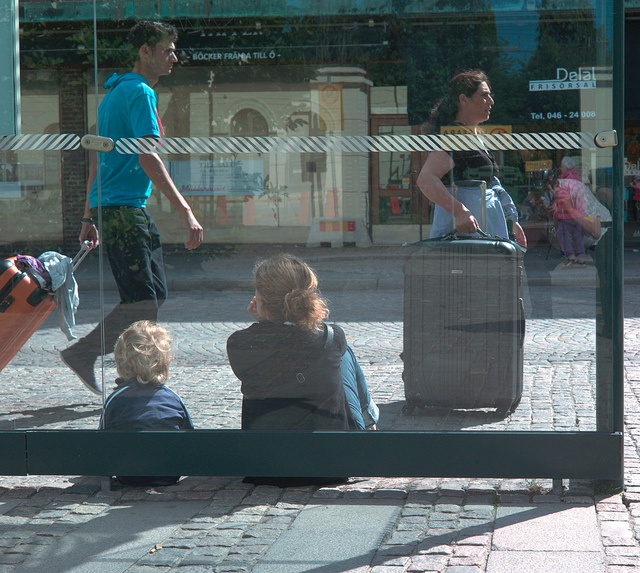Describe the objects in this image and their specific colors. I can see suitcase in teal, purple, and black tones, people in teal, gray, and black tones, people in teal, gray, black, and purple tones, people in teal, gray, black, and blue tones, and people in teal, gray, blue, darkblue, and black tones in this image. 